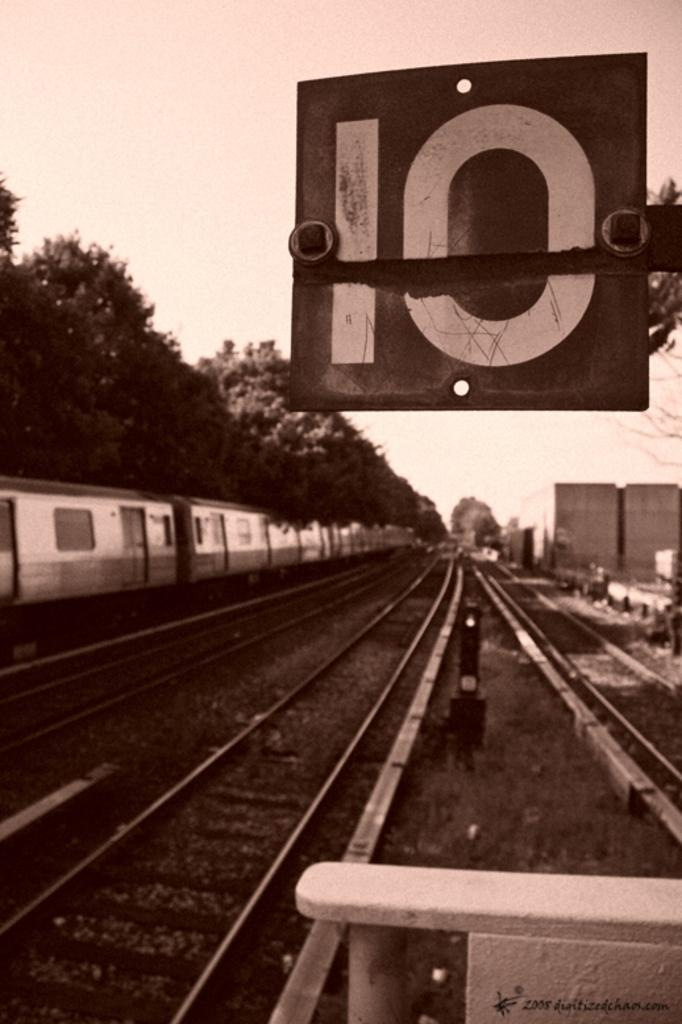<image>
Create a compact narrative representing the image presented. A train on the tracks by a sign with the number 10 on it. 